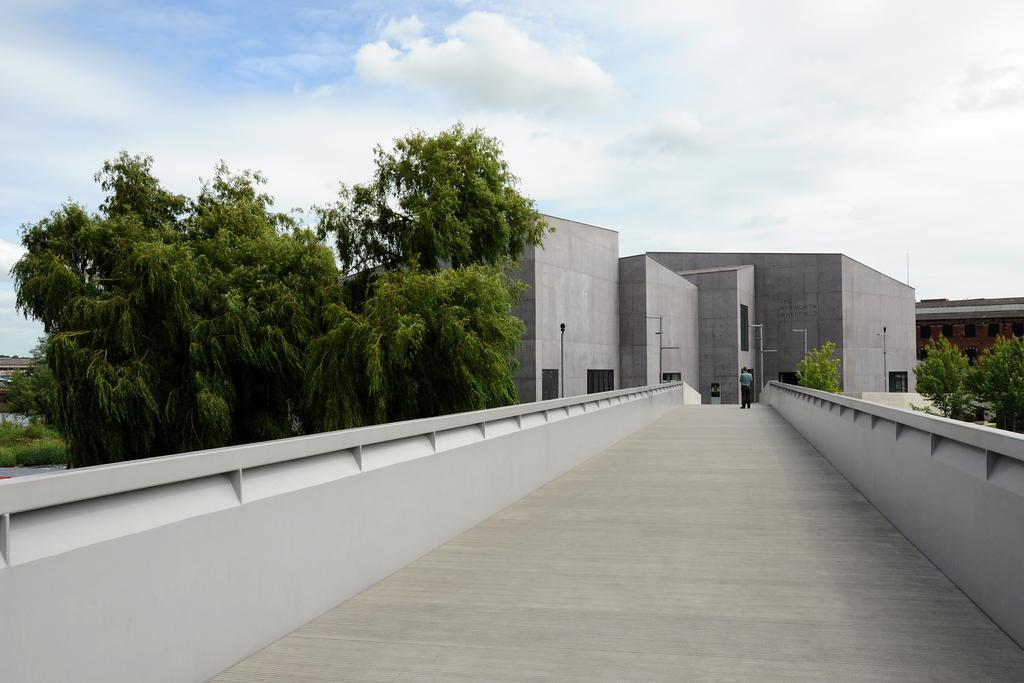What is the main subject of the image? There is a person on a bridge in the image. What can be seen in the background of the image? There are trees and buildings in the background of the image. What objects are visible in the image? There are rods visible in the image. What is visible in the sky at the top of the image? There are clouds in the sky at the top of the image. Where is the crate located in the image? There is no crate present in the image. Can you see any chickens in the image? There are no chickens present in the image. 